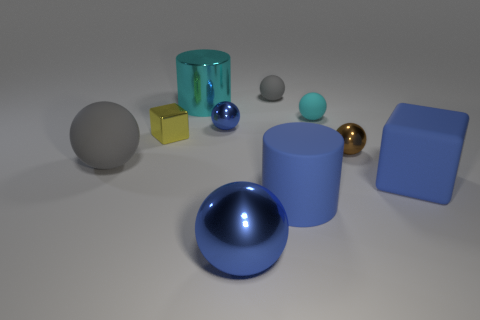Subtract 2 balls. How many balls are left? 4 Subtract all large metal spheres. How many spheres are left? 5 Subtract all brown balls. How many balls are left? 5 Subtract all blue balls. Subtract all red cubes. How many balls are left? 4 Subtract all blocks. How many objects are left? 8 Add 1 red rubber spheres. How many red rubber spheres exist? 1 Subtract 0 yellow balls. How many objects are left? 10 Subtract all big blue things. Subtract all tiny brown spheres. How many objects are left? 6 Add 2 cyan spheres. How many cyan spheres are left? 3 